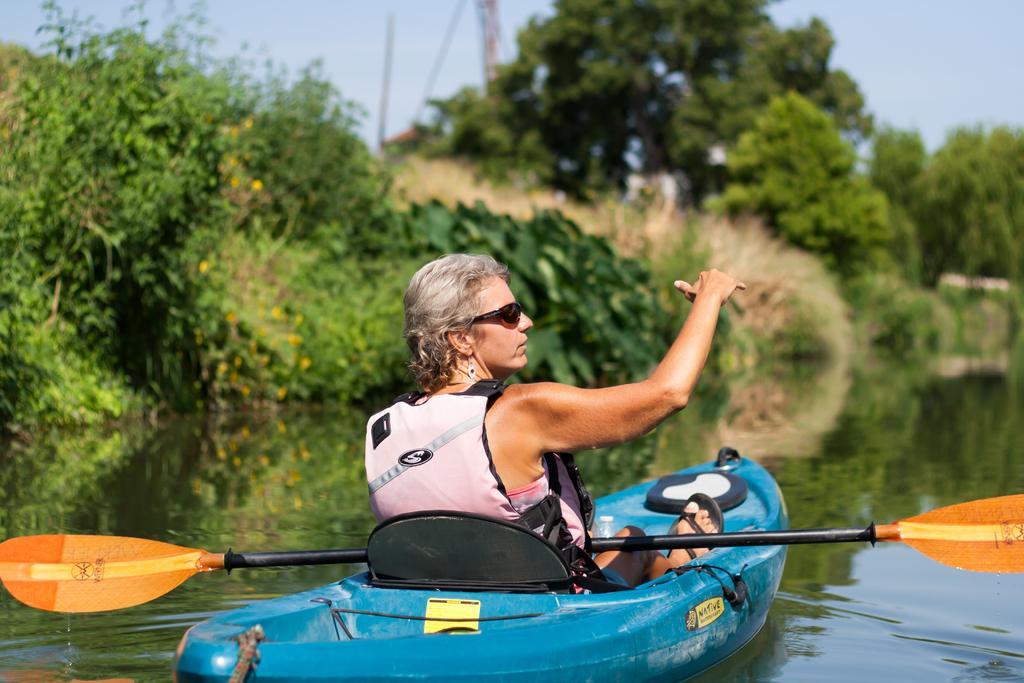Could you give a brief overview of what you see in this image? In the center of the image we can see a lady sitting on the boat. At the bottom there is water and we can see a row. In the background there are trees, pole and sky. 